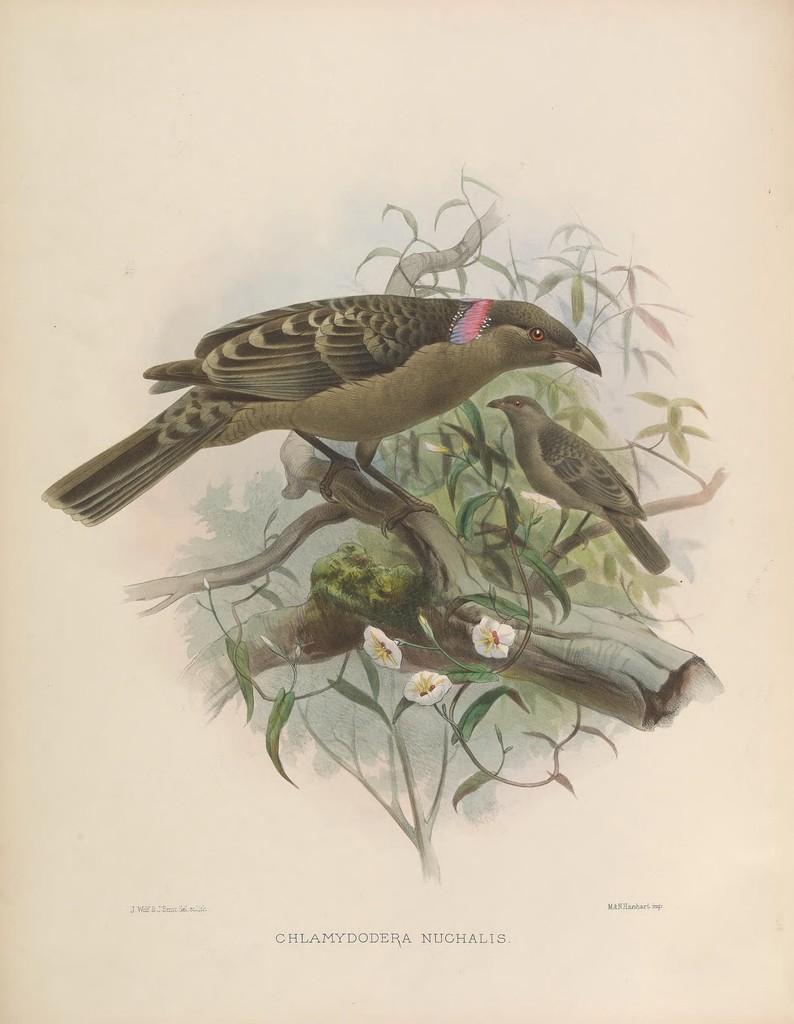Please provide a concise description of this image. This image is a painting. In this painting we can see birds on the branch. There are flowers. 